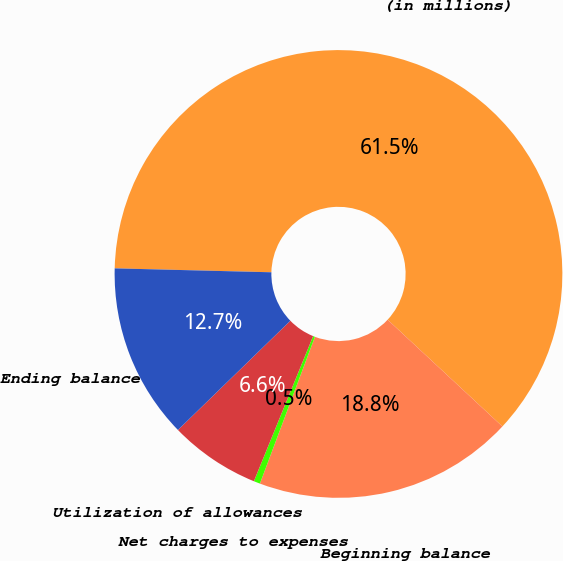Convert chart to OTSL. <chart><loc_0><loc_0><loc_500><loc_500><pie_chart><fcel>(in millions)<fcel>Beginning balance<fcel>Net charges to expenses<fcel>Utilization of allowances<fcel>Ending balance<nl><fcel>61.53%<fcel>18.78%<fcel>0.46%<fcel>6.56%<fcel>12.67%<nl></chart> 